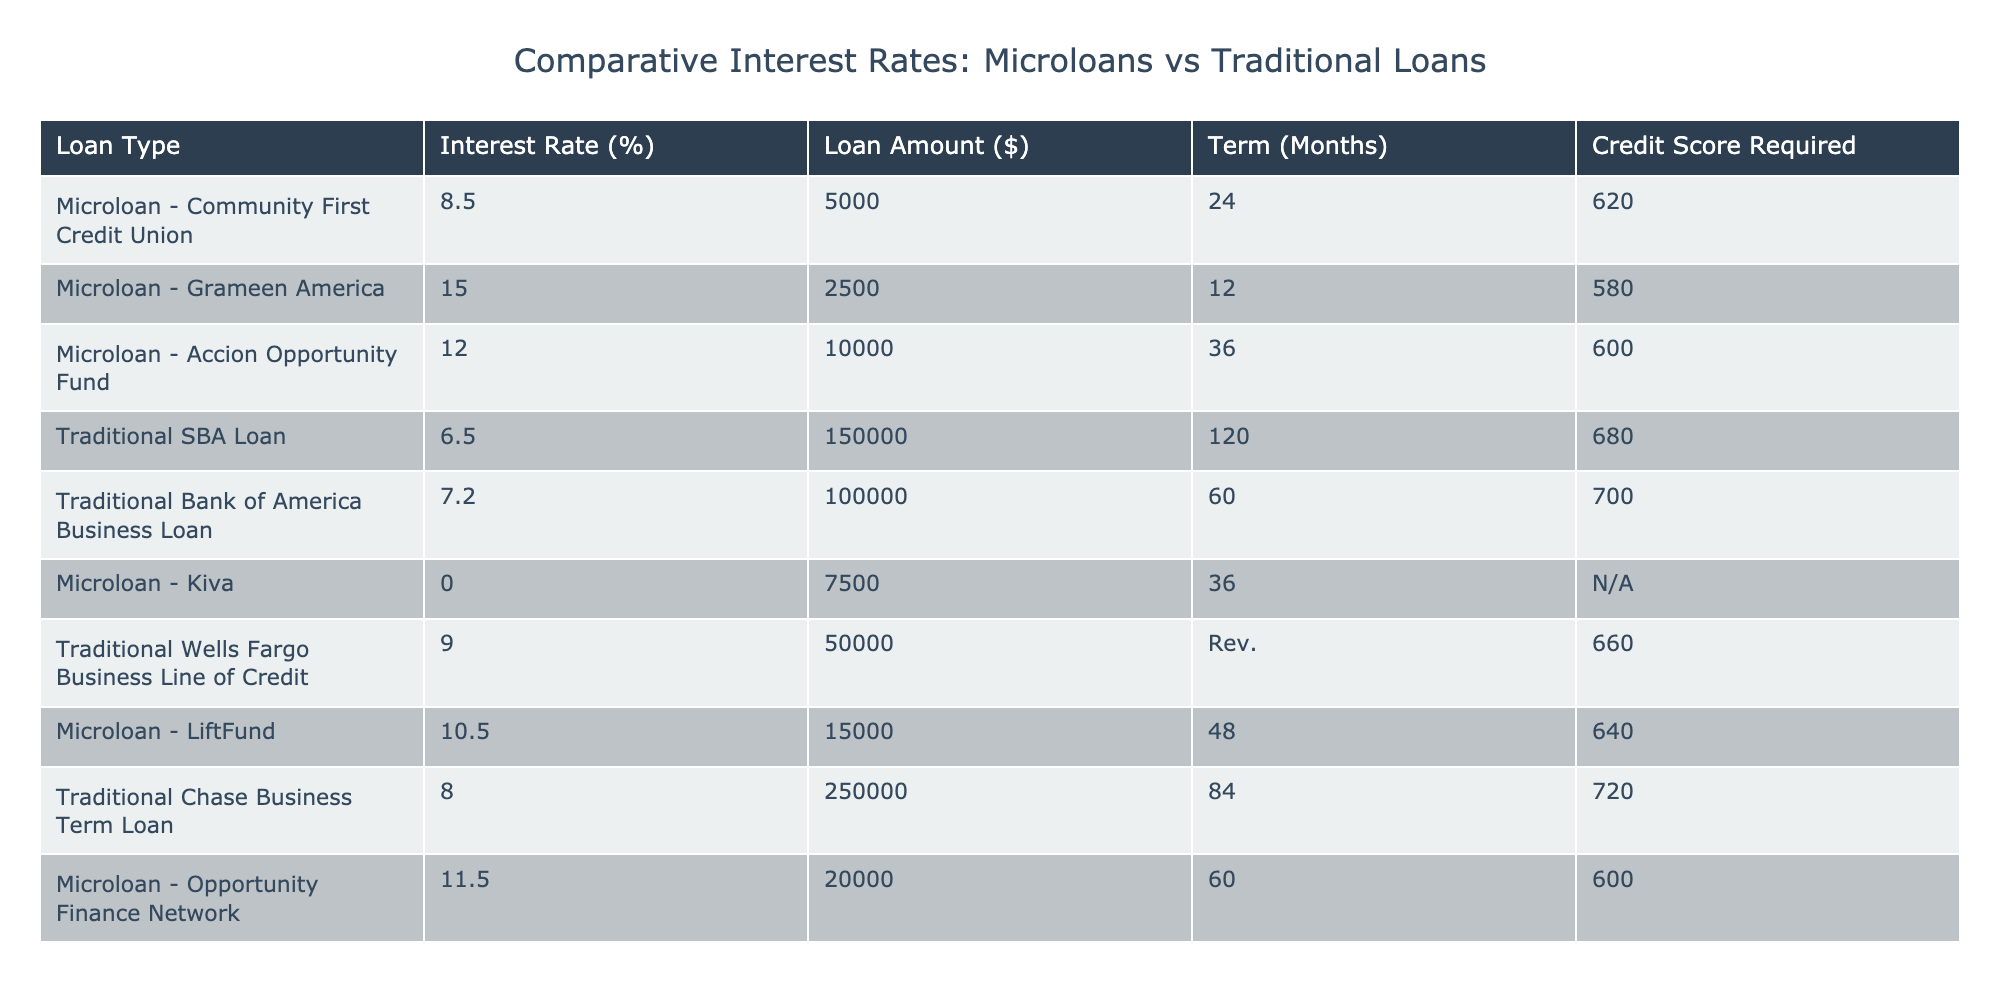What is the interest rate of the Traditional SBA Loan? The table lists the interest rates for various loan types, and the Traditional SBA Loan is shown to have an interest rate of 6.5%.
Answer: 6.5% Which microloan has the highest interest rate? By inspecting the interest rates for all microloans in the table, the Grameen America microloan has the highest interest rate at 15.0%.
Answer: 15.0% Is a credit score of 640 required for any loan in the table? Looking at the "Credit Score Required" column, the LiftFund microloan requires a credit score of 640.
Answer: Yes What is the average interest rate of all microloans listed? The microloans and their interest rates are: 8.5, 15.0, 12.0, 0.0, 10.5, and 11.5. There are 6 loans, so sum = 8.5 + 15 + 12 + 0 + 10.5 + 11.5 = 57.5, and the average = 57.5 / 6 = 9.58%.
Answer: 9.58% What is the difference between the highest and lowest interest rates among traditional loans? The highest interest rate among traditional loans is 9.0% (Wells Fargo Business Line of Credit) and the lowest is 6.5% (Traditional SBA Loan). The difference is 9.0 - 6.5 = 2.5%.
Answer: 2.5% Which loan type has a term longer than 60 months? Observing the "Term (Months)" column, the Traditional Chase Business Term Loan has a term of 84 months, which is longer than 60 months.
Answer: Traditional Chase Business Term Loan Are there any microloans that require no credit score? In the "Credit Score Required" column, the Kiva microloan has "None" listed, indicating that there is no credit score requirement.
Answer: Yes How many total loans are listed in the table? The table contains a total of 10 entries for loans, counting each row under loan types.
Answer: 10 Which category of loan has a lower average interest rate: microloans or traditional loans? The average interest rate for microloans is 9.58% (as calculated previously), and for traditional loans, it is (6.5 + 7.2 + 9.0 + 8.0) / 4 = 7.2%. Since 7.2% < 9.58%, traditional loans have a lower average interest rate.
Answer: Traditional loans What percentage of the total loan amount is represented by microloans? The total loan amount for all loans is 5000 + 2500 + 10000 + 150000 + 100000 + 7500 + 50000 + 15000 + 20000 = 333000, and the microloan total is 5000 + 2500 + 10000 + 7500 + 15000 + 20000 = 50000. The percentage is (50000 / 333000) * 100 ≈ 15.02%.
Answer: 15.02% 